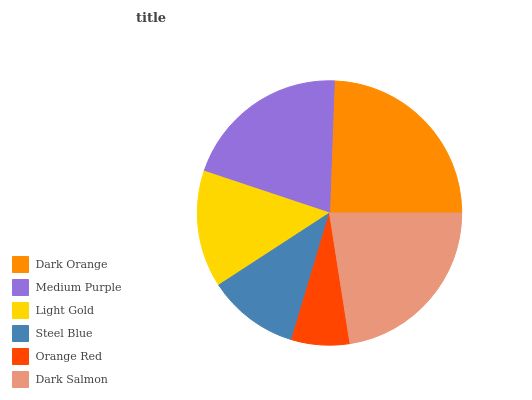Is Orange Red the minimum?
Answer yes or no. Yes. Is Dark Orange the maximum?
Answer yes or no. Yes. Is Medium Purple the minimum?
Answer yes or no. No. Is Medium Purple the maximum?
Answer yes or no. No. Is Dark Orange greater than Medium Purple?
Answer yes or no. Yes. Is Medium Purple less than Dark Orange?
Answer yes or no. Yes. Is Medium Purple greater than Dark Orange?
Answer yes or no. No. Is Dark Orange less than Medium Purple?
Answer yes or no. No. Is Medium Purple the high median?
Answer yes or no. Yes. Is Light Gold the low median?
Answer yes or no. Yes. Is Steel Blue the high median?
Answer yes or no. No. Is Dark Salmon the low median?
Answer yes or no. No. 